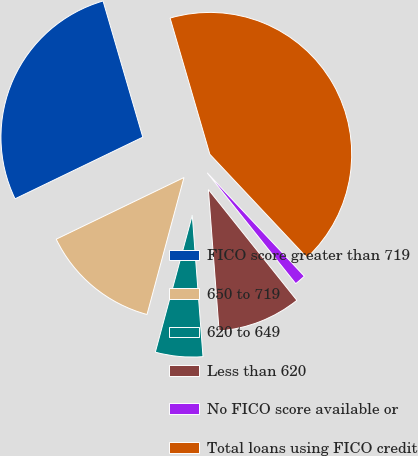Convert chart. <chart><loc_0><loc_0><loc_500><loc_500><pie_chart><fcel>FICO score greater than 719<fcel>650 to 719<fcel>620 to 649<fcel>Less than 620<fcel>No FICO score available or<fcel>Total loans using FICO credit<nl><fcel>27.64%<fcel>13.65%<fcel>5.4%<fcel>9.52%<fcel>1.28%<fcel>42.52%<nl></chart> 